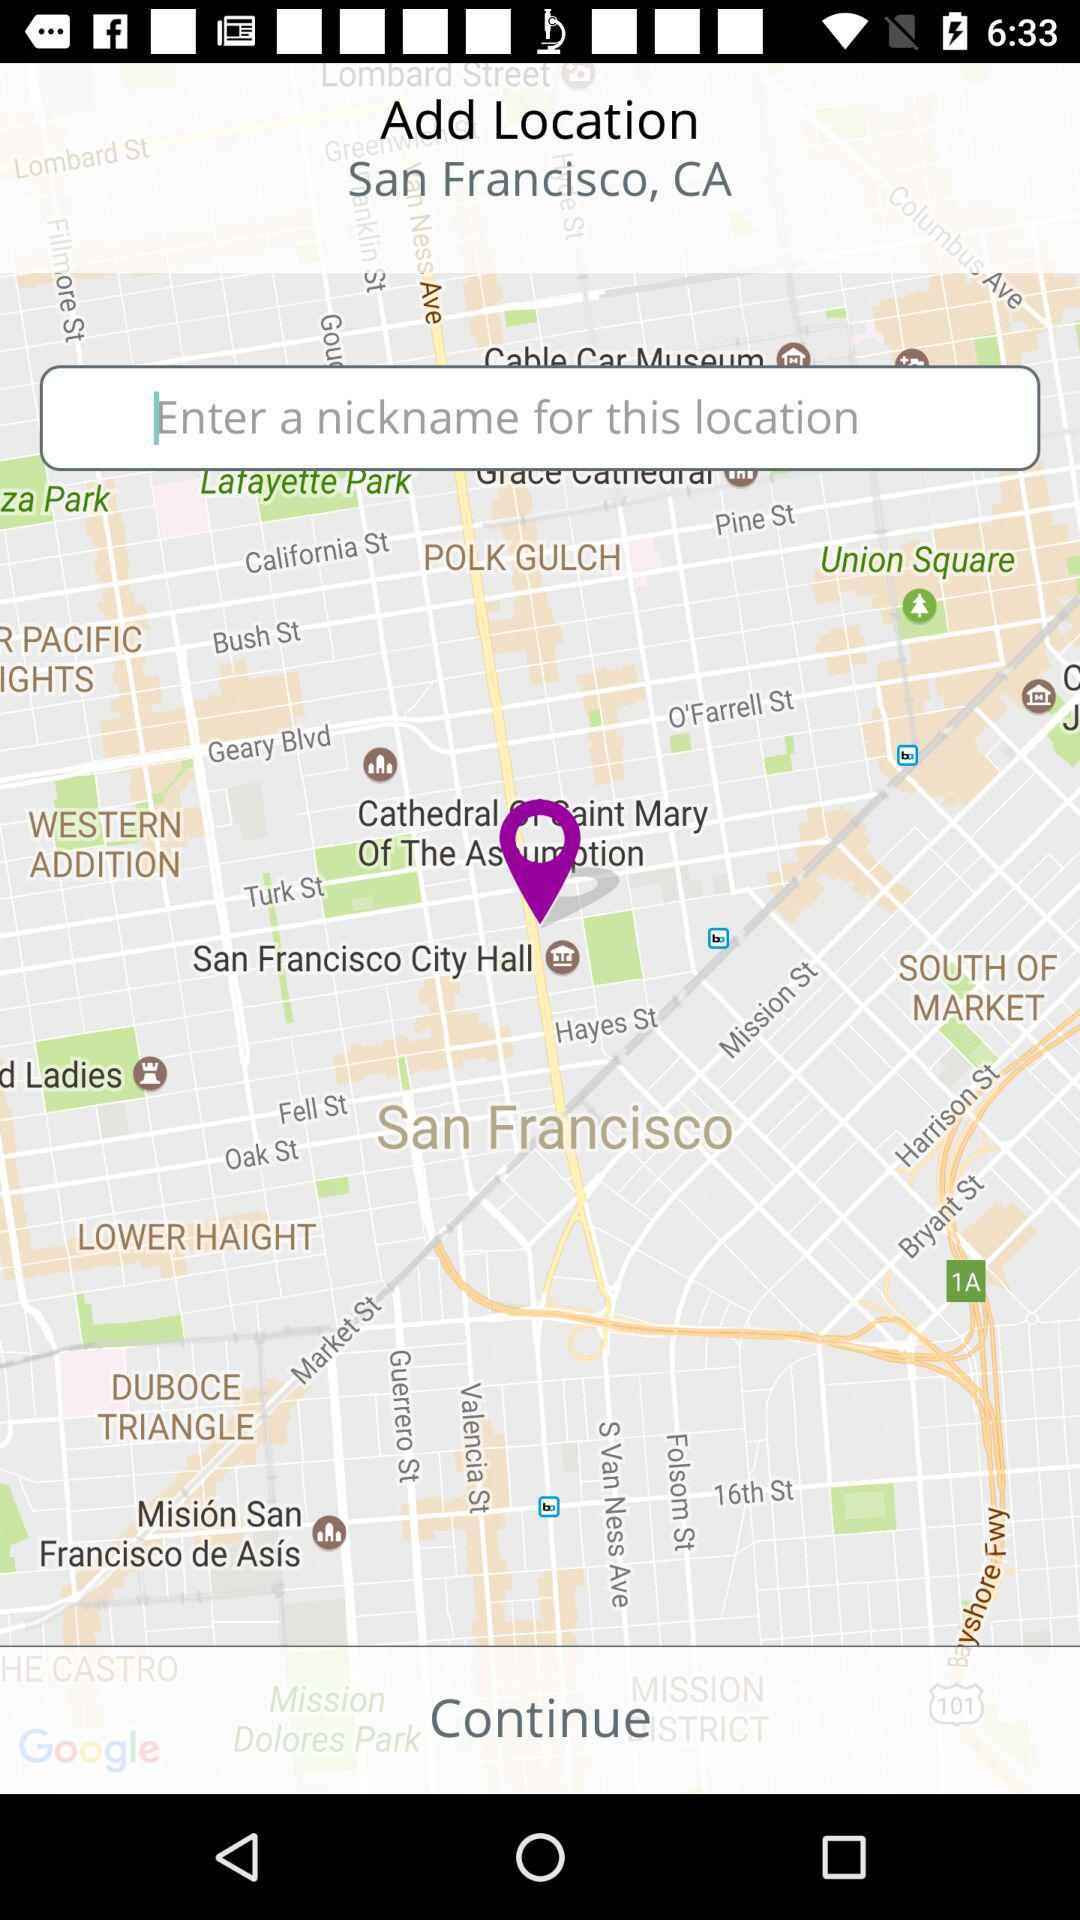What is the selected location? The selected location is San Francisco, CA. 